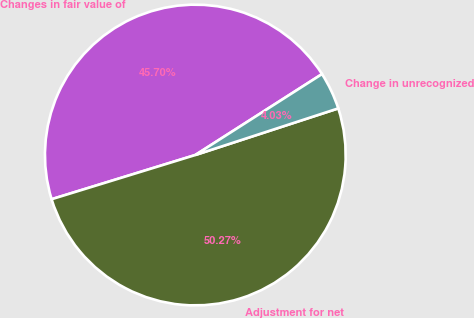Convert chart. <chart><loc_0><loc_0><loc_500><loc_500><pie_chart><fcel>Changes in fair value of<fcel>Adjustment for net<fcel>Change in unrecognized<nl><fcel>45.7%<fcel>50.27%<fcel>4.03%<nl></chart> 